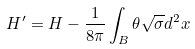Convert formula to latex. <formula><loc_0><loc_0><loc_500><loc_500>H ^ { \prime } = H - \frac { 1 } { 8 \pi } \int _ { B } \theta \sqrt { \sigma } d ^ { 2 } x</formula> 